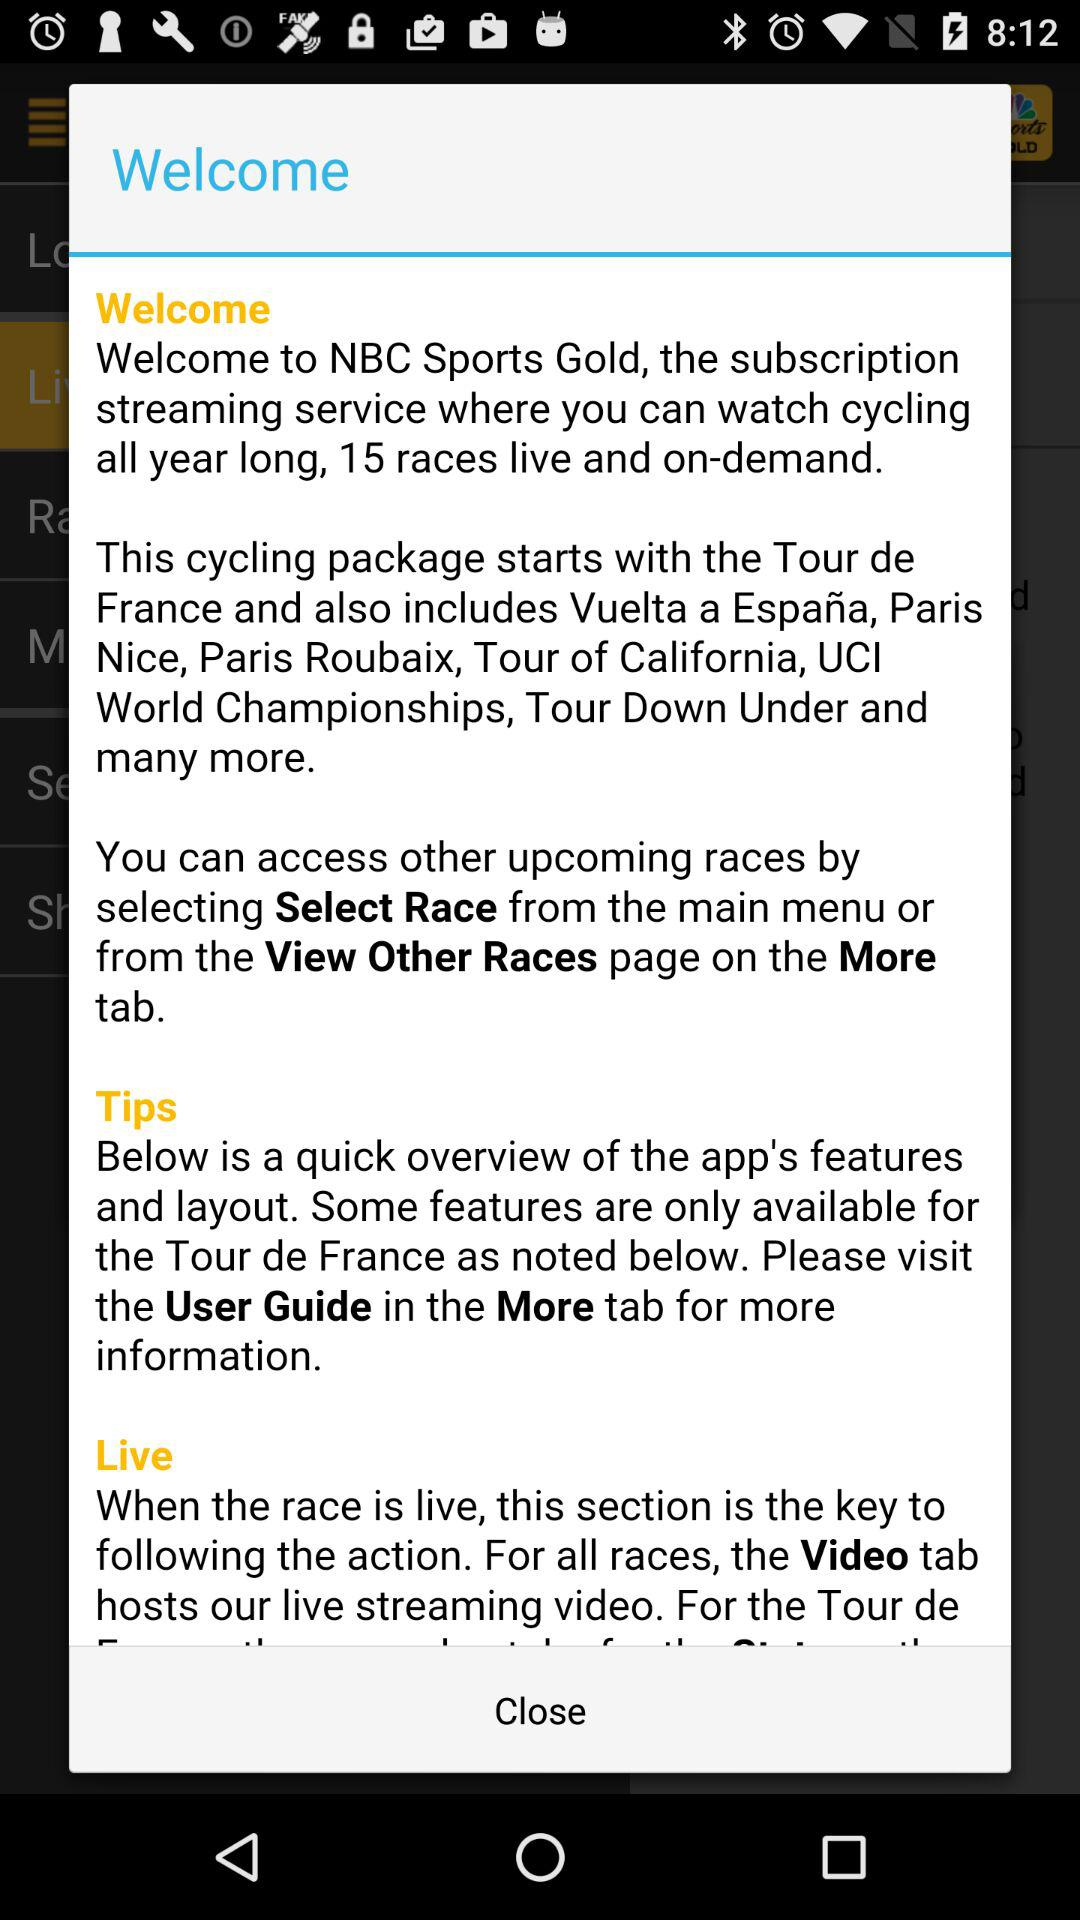What is "NBC Sports Gold"? It is a subscription streaming service where you can watch cycling all year long, 15 races live and on-demand. 